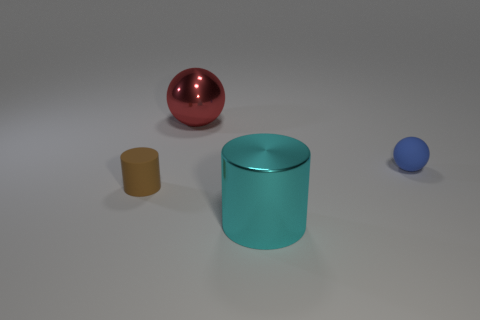Are the ball behind the small ball and the object that is left of the red metallic ball made of the same material?
Your response must be concise. No. There is another small object that is the same shape as the red thing; what material is it?
Give a very brief answer. Rubber. Is the number of large things that are right of the big red metal ball greater than the number of small cyan cylinders?
Offer a terse response. Yes. What is the shape of the thing that is on the right side of the large cyan cylinder?
Ensure brevity in your answer.  Sphere. How many other things are the same shape as the cyan metallic thing?
Make the answer very short. 1. Are the small object behind the tiny brown thing and the brown thing made of the same material?
Provide a short and direct response. Yes. Are there an equal number of cylinders behind the big red metal sphere and metallic things on the left side of the tiny brown thing?
Your answer should be compact. Yes. What is the size of the cylinder right of the tiny brown object?
Make the answer very short. Large. Is there a big cylinder made of the same material as the red sphere?
Your answer should be very brief. Yes. Is the number of big cyan things that are in front of the large cyan cylinder the same as the number of small cylinders?
Your answer should be compact. No. 